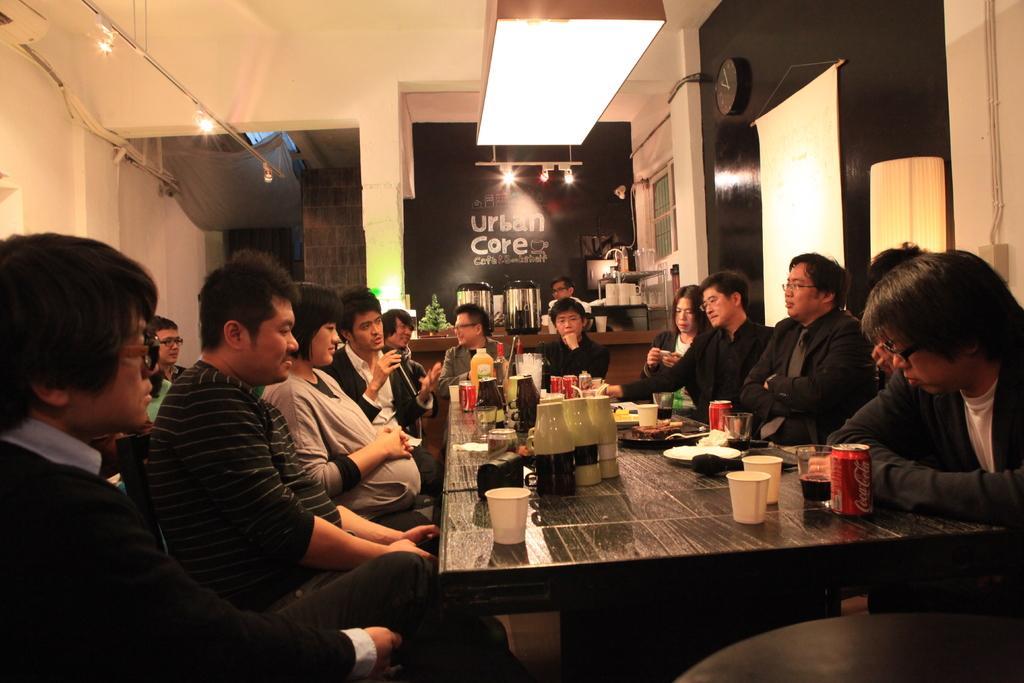How would you summarize this image in a sentence or two? In this picture there are group of people sitting, there is a table in front of them which has some beverage cans, water glasses and disposable glasses and some food served in a plate. In the backdrop there is a wall and onto the ceiling there is a light 